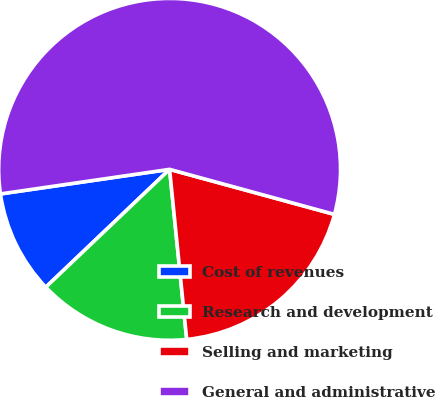<chart> <loc_0><loc_0><loc_500><loc_500><pie_chart><fcel>Cost of revenues<fcel>Research and development<fcel>Selling and marketing<fcel>General and administrative<nl><fcel>9.81%<fcel>14.49%<fcel>19.16%<fcel>56.54%<nl></chart> 